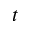Convert formula to latex. <formula><loc_0><loc_0><loc_500><loc_500>t</formula> 